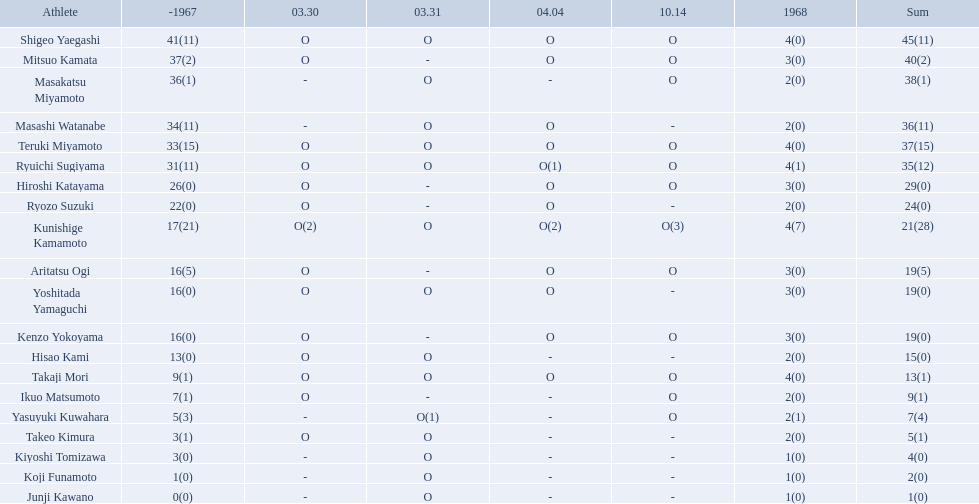Who were the players in the 1968 japanese football? Shigeo Yaegashi, Mitsuo Kamata, Masakatsu Miyamoto, Masashi Watanabe, Teruki Miyamoto, Ryuichi Sugiyama, Hiroshi Katayama, Ryozo Suzuki, Kunishige Kamamoto, Aritatsu Ogi, Yoshitada Yamaguchi, Kenzo Yokoyama, Hisao Kami, Takaji Mori, Ikuo Matsumoto, Yasuyuki Kuwahara, Takeo Kimura, Kiyoshi Tomizawa, Koji Funamoto, Junji Kawano. How many points total did takaji mori have? 13(1). How many points total did junju kawano? 1(0). Who had more points? Takaji Mori. How many points did takaji mori have? 13(1). And how many points did junji kawano have? 1(0). To who does the higher of these belong to? Takaji Mori. Who are all of the players? Shigeo Yaegashi, Mitsuo Kamata, Masakatsu Miyamoto, Masashi Watanabe, Teruki Miyamoto, Ryuichi Sugiyama, Hiroshi Katayama, Ryozo Suzuki, Kunishige Kamamoto, Aritatsu Ogi, Yoshitada Yamaguchi, Kenzo Yokoyama, Hisao Kami, Takaji Mori, Ikuo Matsumoto, Yasuyuki Kuwahara, Takeo Kimura, Kiyoshi Tomizawa, Koji Funamoto, Junji Kawano. How many points did they receive? 45(11), 40(2), 38(1), 36(11), 37(15), 35(12), 29(0), 24(0), 21(28), 19(5), 19(0), 19(0), 15(0), 13(1), 9(1), 7(4), 5(1), 4(0), 2(0), 1(0). What about just takaji mori and junji kawano? 13(1), 1(0). Of the two, who had more points? Takaji Mori. 